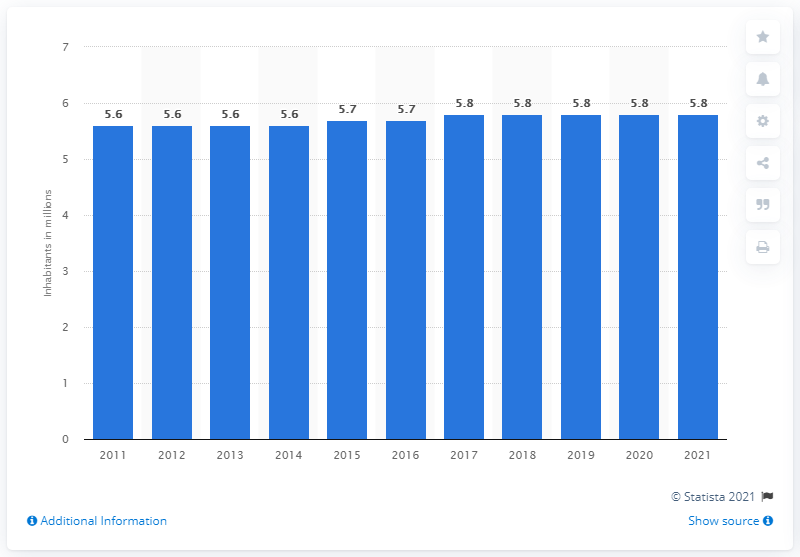Draw attention to some important aspects in this diagram. In 2017, the population of Denmark was approximately 5.8 million. 